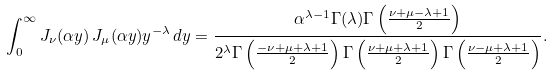<formula> <loc_0><loc_0><loc_500><loc_500>\int _ { 0 } ^ { \infty } J _ { \nu } ( \alpha y ) \, J _ { \mu } ( \alpha y ) y ^ { - \lambda } \, d y = \frac { \alpha ^ { \lambda - 1 } \Gamma ( \lambda ) \Gamma \left ( \frac { \nu + \mu - \lambda + 1 } { 2 } \right ) } { 2 ^ { \lambda } \Gamma \left ( \frac { - \nu + \mu + \lambda + 1 } { 2 } \right ) \Gamma \left ( \frac { \nu + \mu + \lambda + 1 } { 2 } \right ) \Gamma \left ( \frac { \nu - \mu + \lambda + 1 } { 2 } \right ) } .</formula> 